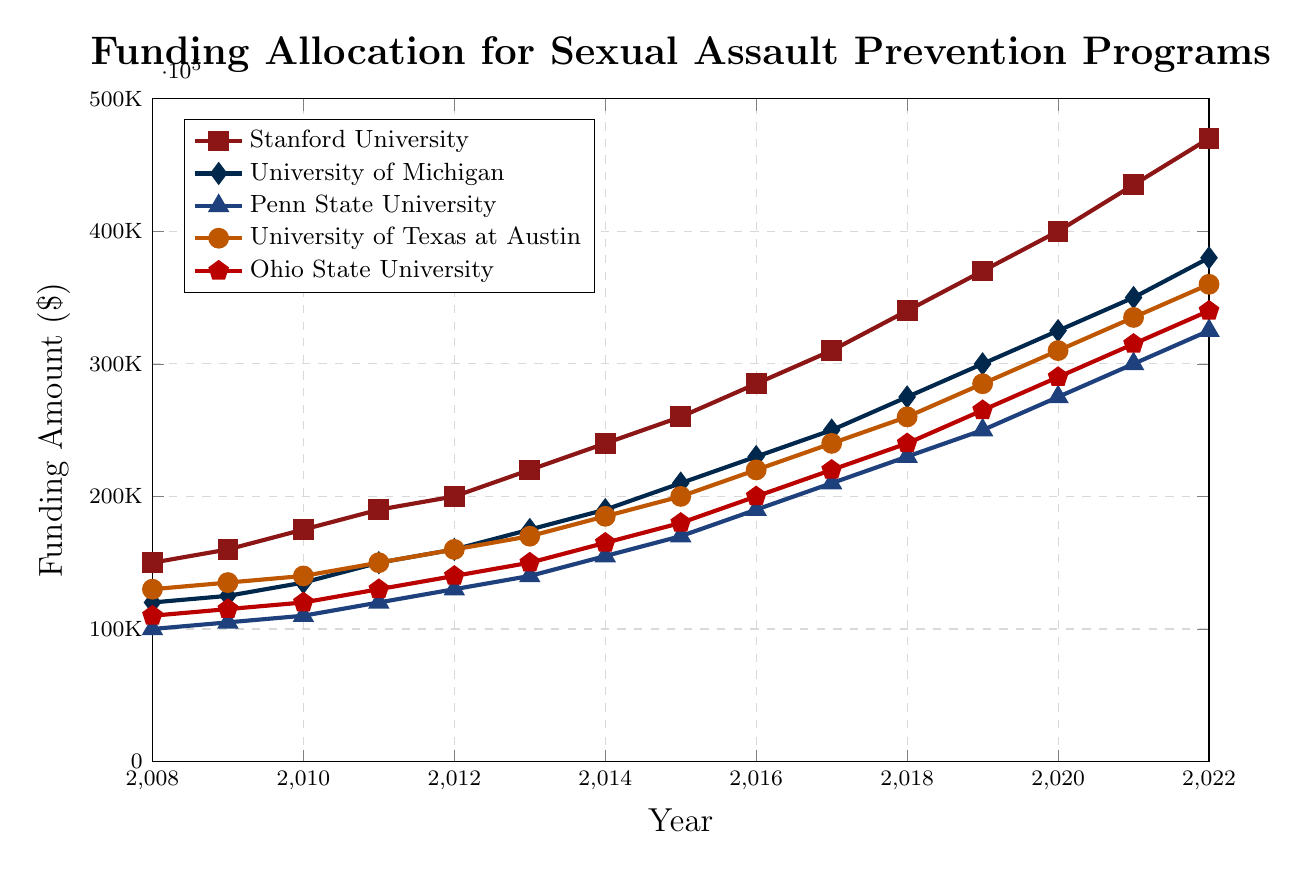What's the overall trend in funding for Stanford University over the 15-year period? The funding for Stanford University shows a consistently increasing trend over the 15 years displayed in the chart. It started at $150,000 in 2008 and increased to $470,000 in 2022.
Answer: Increasing trend Which university had the highest funding allocation in 2022? By examining the funding amounts for each university in 2022, Stanford University has the highest funding at $470,000.
Answer: Stanford University How much did the funding for University of Texas at Austin increase from 2010 to 2020? In 2010, the funding for University of Texas at Austin was $140,000, and in 2020, it was $310,000. The increase is calculated as $310,000 - $140,000.
Answer: $170,000 In which year did Ohio State University break the $200,000 mark in funding? By looking at the plotted line for Ohio State University, the funding crossed $200,000 in 2016, where the allocation was exactly $200,000.
Answer: 2016 What is the average funding allocation over the period for Penn State University? To find the average, sum the yearly funding amounts from 2008 to 2022 and divide by the number of years (15). The sum is $3,665,000, so the average is $3,665,000 / 15.
Answer: $244,333.33 Which university had the smallest increase in funding between 2008 and 2022? By calculating the difference in funding between 2022 and 2008 for each university: 
- Stanford University: $470,000 - $150,000 = $320,000
- University of Michigan: $380,000 - $120,000 = $260,000 
- Penn State University: $325,000 - $100,000 = $225,000 
- University of Texas at Austin: $360,000 - $130,000 = $230,000 
- Ohio State University: $340,000 - $110,000 = $230,000
  
Penn State University had the smallest increase.
Answer: Penn State University By how much did the funding for University of Michigan exceed the funding for Ohio State University in 2022? In 2022, the funding for University of Michigan is $380,000 and for Ohio State University is $340,000. The difference is $380,000 - $340,000.
Answer: $40,000 What was the relative difference in funding allocations between Stanford University and Penn State University in 2019? In 2019, the funding for Stanford University was $370,000 and for Penn State University was $250,000. The relative difference is calculated as ($370,000 - $250,000) / $250,000 * 100%.
Answer: 48% Which universities consistently had their funding allocations beneath $300,000 until 2018? By observing the funding trends, Penn State University is the only one whose funding allocations remained beneath $300,000 until 2018.
Answer: Penn State University 